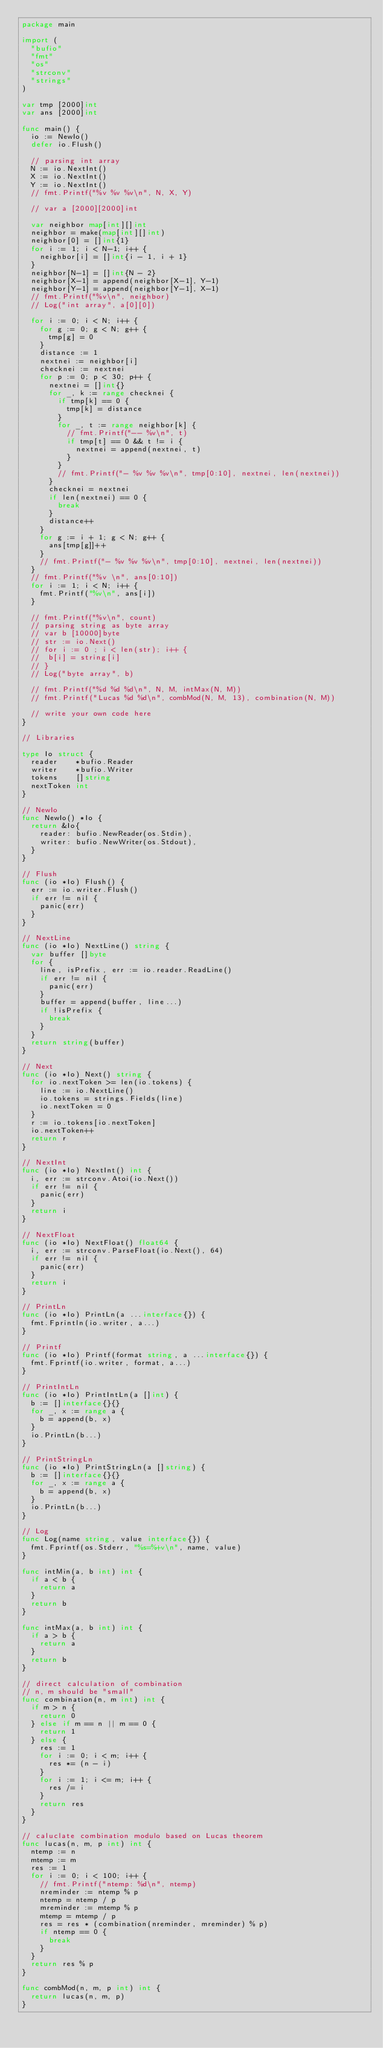Convert code to text. <code><loc_0><loc_0><loc_500><loc_500><_Go_>package main

import (
	"bufio"
	"fmt"
	"os"
	"strconv"
	"strings"
)

var tmp [2000]int
var ans [2000]int

func main() {
	io := NewIo()
	defer io.Flush()

	// parsing int array
	N := io.NextInt()
	X := io.NextInt()
	Y := io.NextInt()
	// fmt.Printf("%v %v %v\n", N, X, Y)

	// var a [2000][2000]int

	var neighbor map[int][]int
	neighbor = make(map[int][]int)
	neighbor[0] = []int{1}
	for i := 1; i < N-1; i++ {
		neighbor[i] = []int{i - 1, i + 1}
	}
	neighbor[N-1] = []int{N - 2}
	neighbor[X-1] = append(neighbor[X-1], Y-1)
	neighbor[Y-1] = append(neighbor[Y-1], X-1)
	// fmt.Printf("%v\n", neighbor)
	// Log("int array", a[0][0])

	for i := 0; i < N; i++ {
		for g := 0; g < N; g++ {
			tmp[g] = 0
		}
		distance := 1
		nextnei := neighbor[i]
		checknei := nextnei
		for p := 0; p < 30; p++ {
			nextnei = []int{}
			for _, k := range checknei {
				if tmp[k] == 0 {
					tmp[k] = distance
				}
				for _, t := range neighbor[k] {
					// fmt.Printf("-- %v\n", t)
					if tmp[t] == 0 && t != i {
						nextnei = append(nextnei, t)
					}
				}
				// fmt.Printf("- %v %v %v\n", tmp[0:10], nextnei, len(nextnei))
			}
			checknei = nextnei
			if len(nextnei) == 0 {
				break
			}
			distance++
		}
		for g := i + 1; g < N; g++ {
			ans[tmp[g]]++
		}
		// fmt.Printf("- %v %v %v\n", tmp[0:10], nextnei, len(nextnei))
	}
	// fmt.Printf("%v \n", ans[0:10])
	for i := 1; i < N; i++ {
		fmt.Printf("%v\n", ans[i])
	}

	// fmt.Printf("%v\n", count)
	// parsing string as byte array
	// var b [10000]byte
	// str := io.Next()
	// for i := 0 ; i < len(str); i++ {
	// 	b[i] = string[i]
	// }
	// Log("byte array", b)

	// fmt.Printf("%d %d %d\n", N, M, intMax(N, M))
	// fmt.Printf("Lucas %d %d\n", combMod(N, M, 13), combination(N, M))

	// write your own code here
}

// Libraries

type Io struct {
	reader    *bufio.Reader
	writer    *bufio.Writer
	tokens    []string
	nextToken int
}

// NewIo
func NewIo() *Io {
	return &Io{
		reader: bufio.NewReader(os.Stdin),
		writer: bufio.NewWriter(os.Stdout),
	}
}

// Flush
func (io *Io) Flush() {
	err := io.writer.Flush()
	if err != nil {
		panic(err)
	}
}

// NextLine
func (io *Io) NextLine() string {
	var buffer []byte
	for {
		line, isPrefix, err := io.reader.ReadLine()
		if err != nil {
			panic(err)
		}
		buffer = append(buffer, line...)
		if !isPrefix {
			break
		}
	}
	return string(buffer)
}

// Next
func (io *Io) Next() string {
	for io.nextToken >= len(io.tokens) {
		line := io.NextLine()
		io.tokens = strings.Fields(line)
		io.nextToken = 0
	}
	r := io.tokens[io.nextToken]
	io.nextToken++
	return r
}

// NextInt
func (io *Io) NextInt() int {
	i, err := strconv.Atoi(io.Next())
	if err != nil {
		panic(err)
	}
	return i
}

// NextFloat
func (io *Io) NextFloat() float64 {
	i, err := strconv.ParseFloat(io.Next(), 64)
	if err != nil {
		panic(err)
	}
	return i
}

// PrintLn
func (io *Io) PrintLn(a ...interface{}) {
	fmt.Fprintln(io.writer, a...)
}

// Printf
func (io *Io) Printf(format string, a ...interface{}) {
	fmt.Fprintf(io.writer, format, a...)
}

// PrintIntLn
func (io *Io) PrintIntLn(a []int) {
	b := []interface{}{}
	for _, x := range a {
		b = append(b, x)
	}
	io.PrintLn(b...)
}

// PrintStringLn
func (io *Io) PrintStringLn(a []string) {
	b := []interface{}{}
	for _, x := range a {
		b = append(b, x)
	}
	io.PrintLn(b...)
}

// Log
func Log(name string, value interface{}) {
	fmt.Fprintf(os.Stderr, "%s=%+v\n", name, value)
}

func intMin(a, b int) int {
	if a < b {
		return a
	}
	return b
}

func intMax(a, b int) int {
	if a > b {
		return a
	}
	return b
}

// direct calculation of combination
// n, m should be "small"
func combination(n, m int) int {
	if m > n {
		return 0
	} else if m == n || m == 0 {
		return 1
	} else {
		res := 1
		for i := 0; i < m; i++ {
			res *= (n - i)
		}
		for i := 1; i <= m; i++ {
			res /= i
		}
		return res
	}
}

// caluclate combination modulo based on Lucas theorem
func lucas(n, m, p int) int {
	ntemp := n
	mtemp := m
	res := 1
	for i := 0; i < 100; i++ {
		// fmt.Printf("ntemp: %d\n", ntemp)
		nreminder := ntemp % p
		ntemp = ntemp / p
		mreminder := mtemp % p
		mtemp = mtemp / p
		res = res * (combination(nreminder, mreminder) % p)
		if ntemp == 0 {
			break
		}
	}
	return res % p
}

func combMod(n, m, p int) int {
	return lucas(n, m, p)
}
</code> 